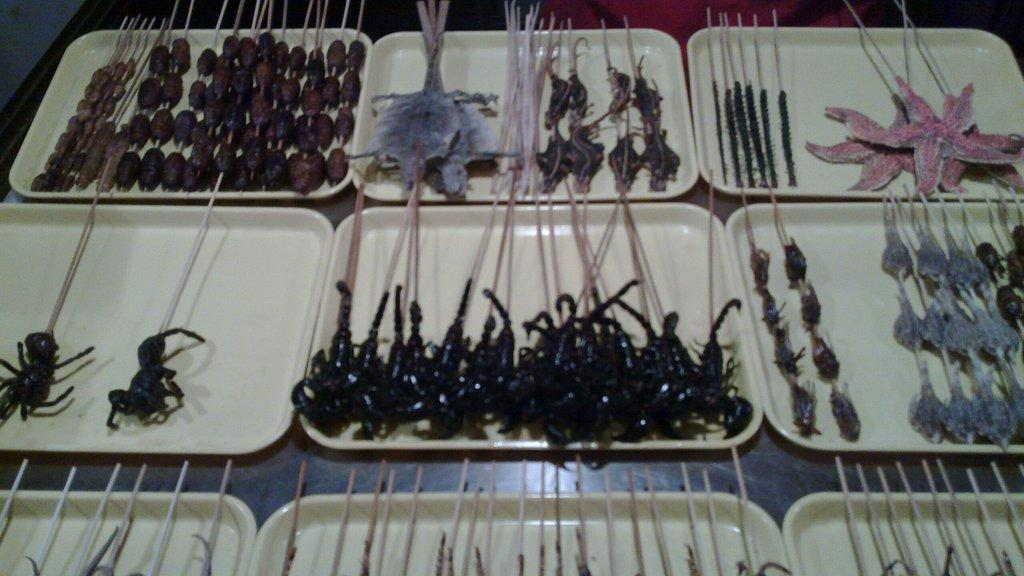What objects are present on the plates in the image? Insects are present on the plates in the image. What other marine creatures can be seen in the image? There are starfish in the top right side of the image. What type of watch can be seen on the starfish in the image? There is no watch present on the starfish in the image. 